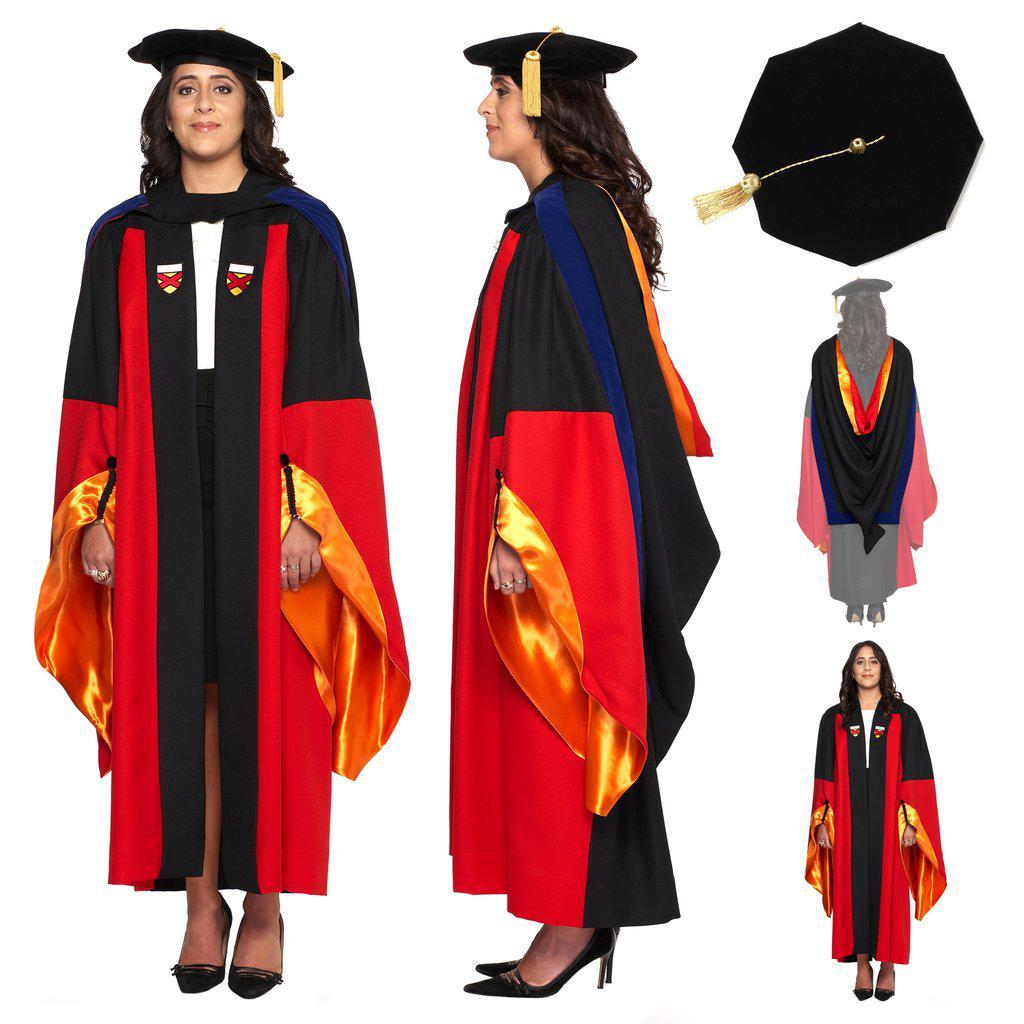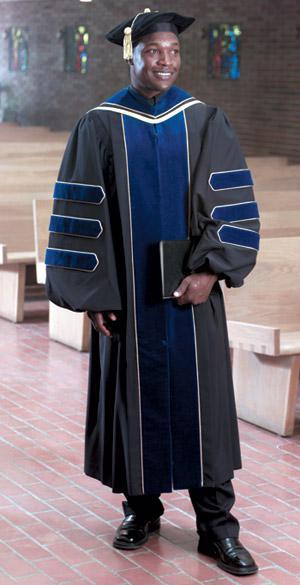The first image is the image on the left, the second image is the image on the right. Analyze the images presented: Is the assertion "There is a woman in the image on the right." valid? Answer yes or no. No. 